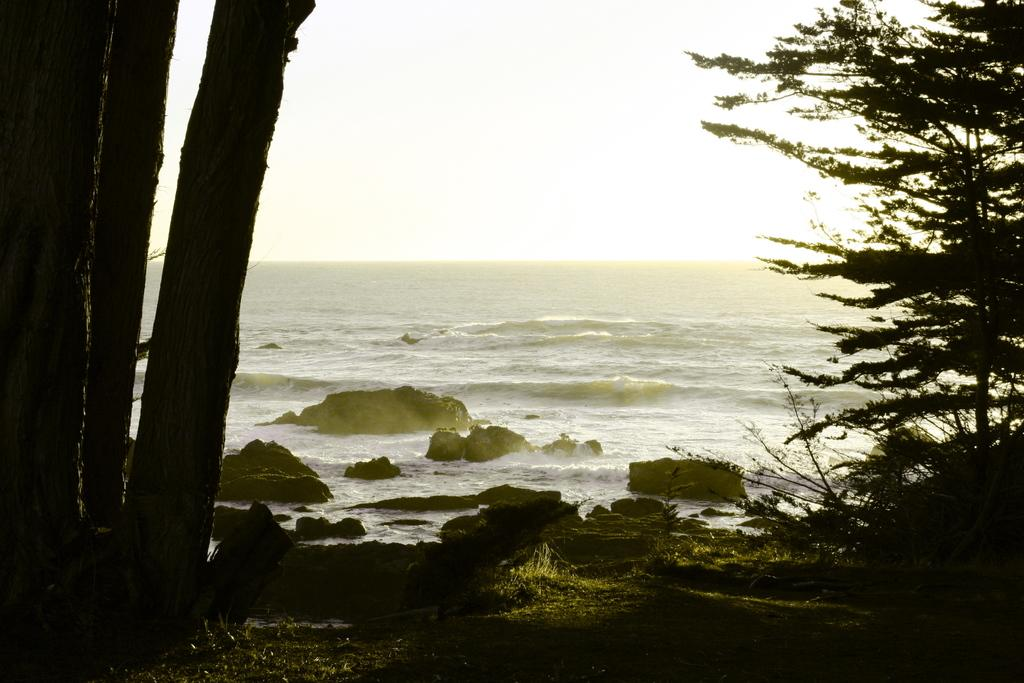What type of vegetation is on the left side of the image? There are trees on the left side of the image. What type of vegetation is on the right side of the image? There are plants on the right side of the image. What can be seen in the background of the image? There is an ocean visible in the background of the image. How much credit is available for the visitor in the image? There is no visitor or credit mentioned in the image; it features trees, plants, and an ocean. What is the distance between the trees and the plants in the image? The image does not provide information about the distance between the trees and plants; it only shows their presence on opposite sides. 